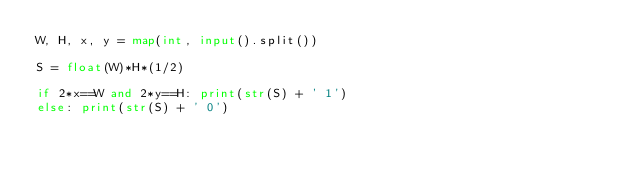<code> <loc_0><loc_0><loc_500><loc_500><_Python_>W, H, x, y = map(int, input().split())

S = float(W)*H*(1/2)

if 2*x==W and 2*y==H: print(str(S) + ' 1')
else: print(str(S) + ' 0')
</code> 